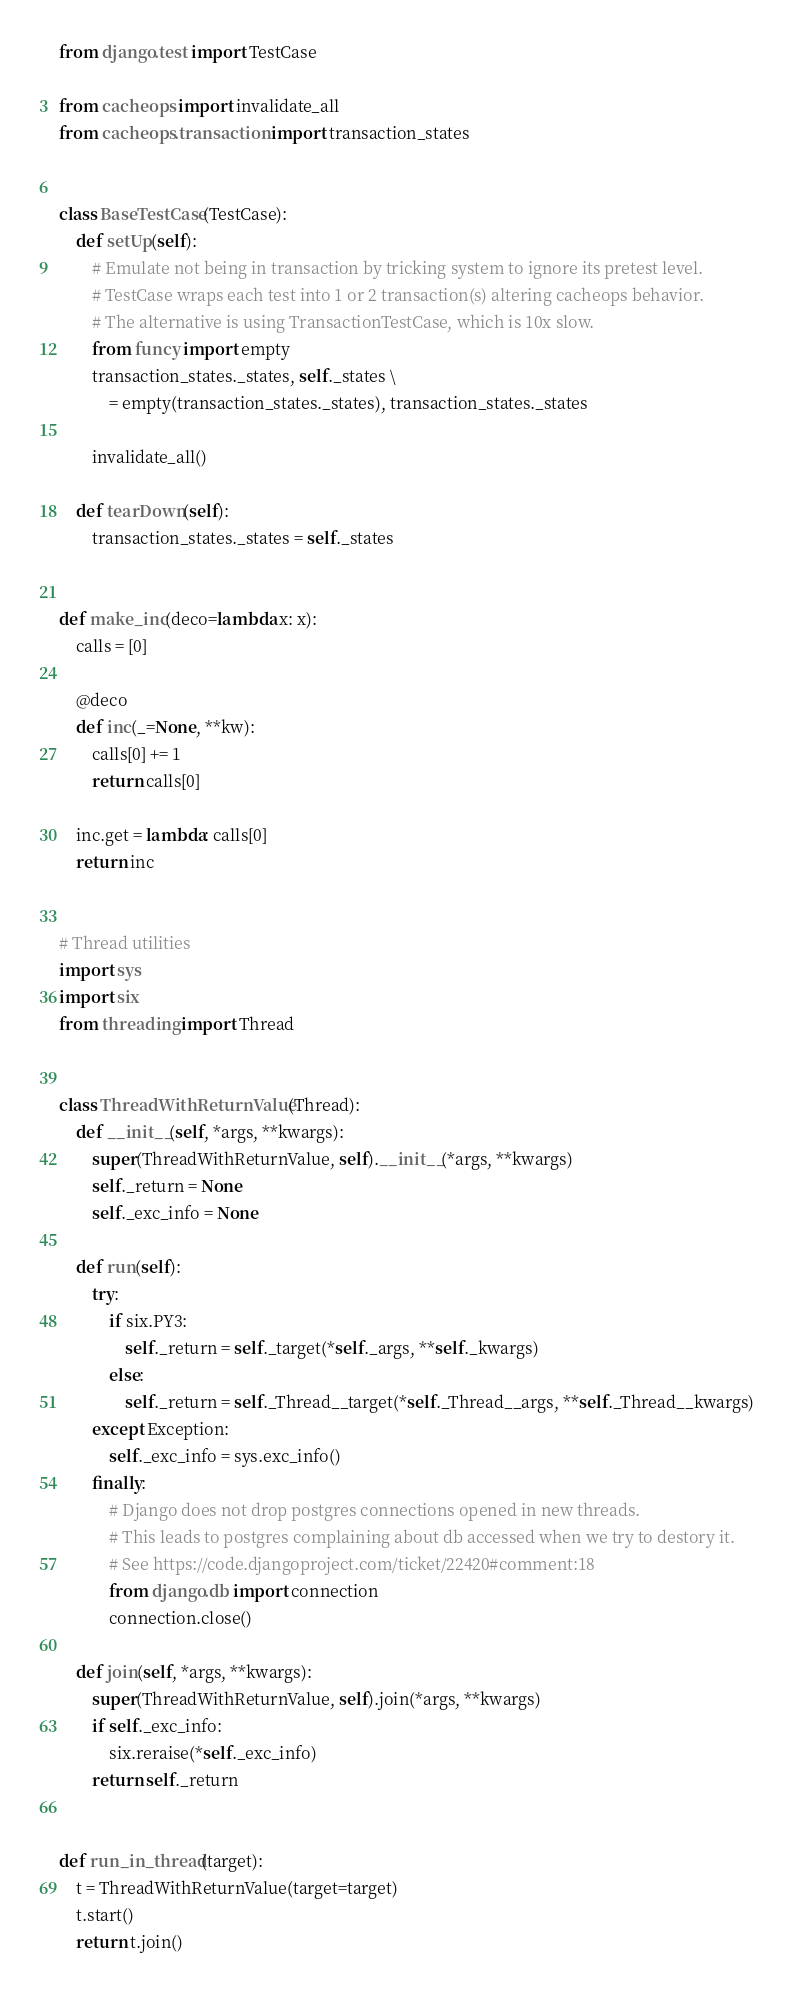Convert code to text. <code><loc_0><loc_0><loc_500><loc_500><_Python_>from django.test import TestCase

from cacheops import invalidate_all
from cacheops.transaction import transaction_states


class BaseTestCase(TestCase):
    def setUp(self):
        # Emulate not being in transaction by tricking system to ignore its pretest level.
        # TestCase wraps each test into 1 or 2 transaction(s) altering cacheops behavior.
        # The alternative is using TransactionTestCase, which is 10x slow.
        from funcy import empty
        transaction_states._states, self._states \
            = empty(transaction_states._states), transaction_states._states

        invalidate_all()

    def tearDown(self):
        transaction_states._states = self._states


def make_inc(deco=lambda x: x):
    calls = [0]

    @deco
    def inc(_=None, **kw):
        calls[0] += 1
        return calls[0]

    inc.get = lambda: calls[0]
    return inc


# Thread utilities
import sys
import six
from threading import Thread


class ThreadWithReturnValue(Thread):
    def __init__(self, *args, **kwargs):
        super(ThreadWithReturnValue, self).__init__(*args, **kwargs)
        self._return = None
        self._exc_info = None

    def run(self):
        try:
            if six.PY3:
                self._return = self._target(*self._args, **self._kwargs)
            else:
                self._return = self._Thread__target(*self._Thread__args, **self._Thread__kwargs)
        except Exception:
            self._exc_info = sys.exc_info()
        finally:
            # Django does not drop postgres connections opened in new threads.
            # This leads to postgres complaining about db accessed when we try to destory it.
            # See https://code.djangoproject.com/ticket/22420#comment:18
            from django.db import connection
            connection.close()

    def join(self, *args, **kwargs):
        super(ThreadWithReturnValue, self).join(*args, **kwargs)
        if self._exc_info:
            six.reraise(*self._exc_info)
        return self._return


def run_in_thread(target):
    t = ThreadWithReturnValue(target=target)
    t.start()
    return t.join()
</code> 